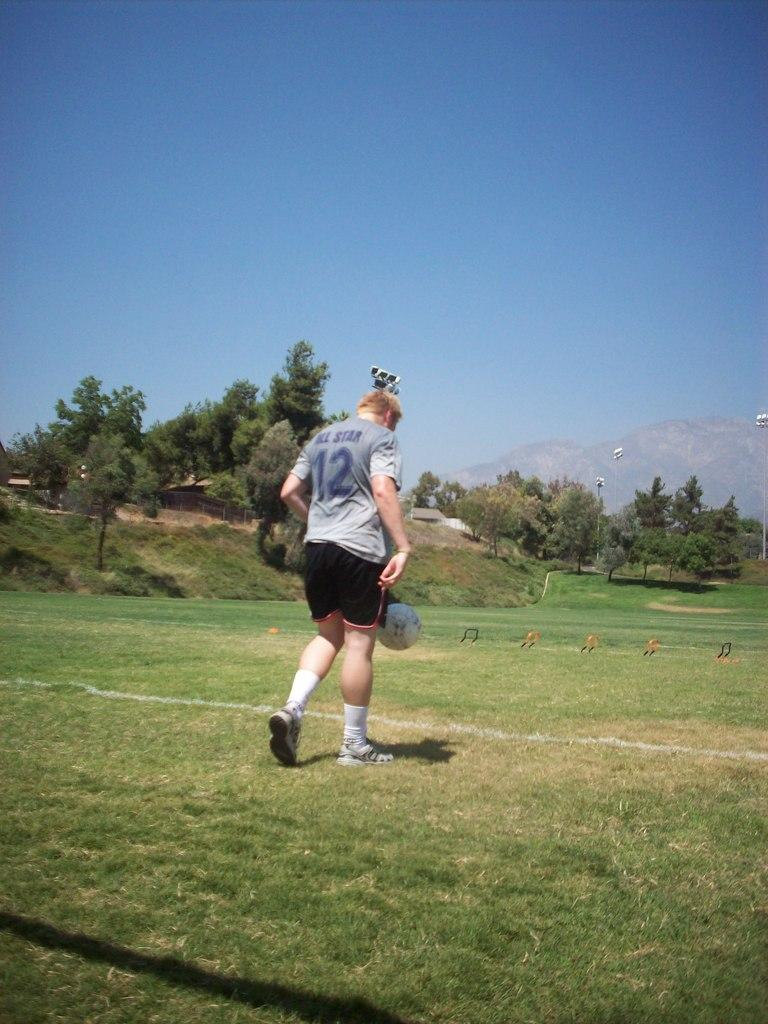<image>
Give a short and clear explanation of the subsequent image. A man wearing a shirt with All Star 12 on it. 